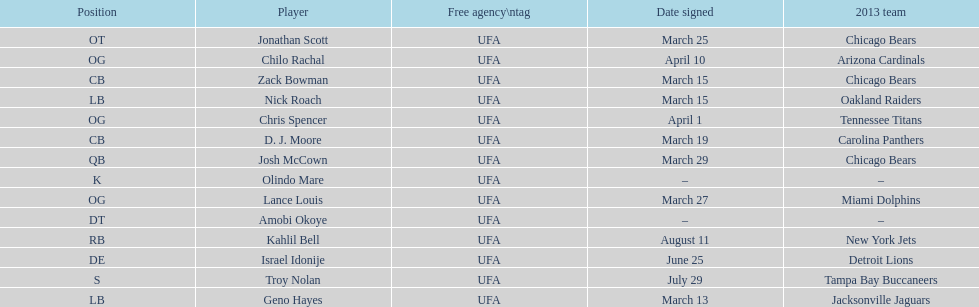How many available players did this team add this season? 14. Could you parse the entire table? {'header': ['Position', 'Player', 'Free agency\\ntag', 'Date signed', '2013 team'], 'rows': [['OT', 'Jonathan Scott', 'UFA', 'March 25', 'Chicago Bears'], ['OG', 'Chilo Rachal', 'UFA', 'April 10', 'Arizona Cardinals'], ['CB', 'Zack Bowman', 'UFA', 'March 15', 'Chicago Bears'], ['LB', 'Nick Roach', 'UFA', 'March 15', 'Oakland Raiders'], ['OG', 'Chris Spencer', 'UFA', 'April 1', 'Tennessee Titans'], ['CB', 'D. J. Moore', 'UFA', 'March 19', 'Carolina Panthers'], ['QB', 'Josh McCown', 'UFA', 'March 29', 'Chicago Bears'], ['K', 'Olindo Mare', 'UFA', '–', '–'], ['OG', 'Lance Louis', 'UFA', 'March 27', 'Miami Dolphins'], ['DT', 'Amobi Okoye', 'UFA', '–', '–'], ['RB', 'Kahlil Bell', 'UFA', 'August 11', 'New York Jets'], ['DE', 'Israel Idonije', 'UFA', 'June 25', 'Detroit Lions'], ['S', 'Troy Nolan', 'UFA', 'July 29', 'Tampa Bay Buccaneers'], ['LB', 'Geno Hayes', 'UFA', 'March 13', 'Jacksonville Jaguars']]} 